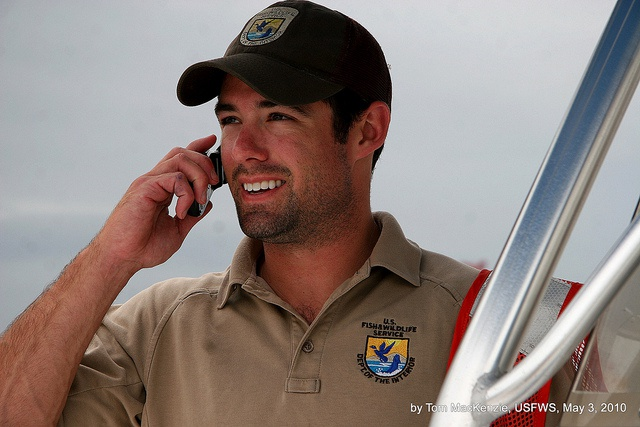Describe the objects in this image and their specific colors. I can see people in darkgray, maroon, brown, black, and gray tones and cell phone in darkgray, black, gray, and maroon tones in this image. 